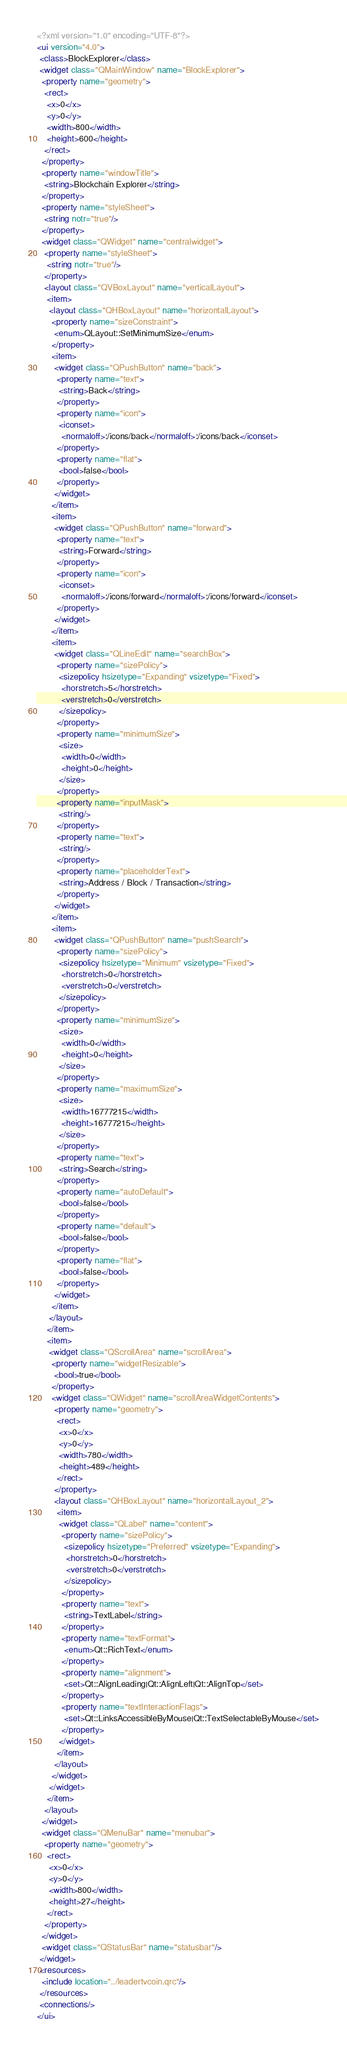Convert code to text. <code><loc_0><loc_0><loc_500><loc_500><_XML_><?xml version="1.0" encoding="UTF-8"?>
<ui version="4.0">
 <class>BlockExplorer</class>
 <widget class="QMainWindow" name="BlockExplorer">
  <property name="geometry">
   <rect>
    <x>0</x>
    <y>0</y>
    <width>800</width>
    <height>600</height>
   </rect>
  </property>
  <property name="windowTitle">
   <string>Blockchain Explorer</string>
  </property>
  <property name="styleSheet">
   <string notr="true"/>
  </property>
  <widget class="QWidget" name="centralwidget">
   <property name="styleSheet">
    <string notr="true"/>
   </property>
   <layout class="QVBoxLayout" name="verticalLayout">
    <item>
     <layout class="QHBoxLayout" name="horizontalLayout">
      <property name="sizeConstraint">
       <enum>QLayout::SetMinimumSize</enum>
      </property>
      <item>
       <widget class="QPushButton" name="back">
        <property name="text">
         <string>Back</string>
        </property>
        <property name="icon">
         <iconset>
          <normaloff>:/icons/back</normaloff>:/icons/back</iconset>
        </property>
        <property name="flat">
         <bool>false</bool>
        </property>
       </widget>
      </item>
      <item>
       <widget class="QPushButton" name="forward">
        <property name="text">
         <string>Forward</string>
        </property>
        <property name="icon">
         <iconset>
          <normaloff>:/icons/forward</normaloff>:/icons/forward</iconset>
        </property>
       </widget>
      </item>
      <item>
       <widget class="QLineEdit" name="searchBox">
        <property name="sizePolicy">
         <sizepolicy hsizetype="Expanding" vsizetype="Fixed">
          <horstretch>5</horstretch>
          <verstretch>0</verstretch>
         </sizepolicy>
        </property>
        <property name="minimumSize">
         <size>
          <width>0</width>
          <height>0</height>
         </size>
        </property>
        <property name="inputMask">
         <string/>
        </property>
        <property name="text">
         <string/>
        </property>
        <property name="placeholderText">
         <string>Address / Block / Transaction</string>
        </property>
       </widget>
      </item>
      <item>
       <widget class="QPushButton" name="pushSearch">
        <property name="sizePolicy">
         <sizepolicy hsizetype="Minimum" vsizetype="Fixed">
          <horstretch>0</horstretch>
          <verstretch>0</verstretch>
         </sizepolicy>
        </property>
        <property name="minimumSize">
         <size>
          <width>0</width>
          <height>0</height>
         </size>
        </property>
        <property name="maximumSize">
         <size>
          <width>16777215</width>
          <height>16777215</height>
         </size>
        </property>
        <property name="text">
         <string>Search</string>
        </property>
        <property name="autoDefault">
         <bool>false</bool>
        </property>
        <property name="default">
         <bool>false</bool>
        </property>
        <property name="flat">
         <bool>false</bool>
        </property>
       </widget>
      </item>
     </layout>
    </item>
    <item>
     <widget class="QScrollArea" name="scrollArea">
      <property name="widgetResizable">
       <bool>true</bool>
      </property>
      <widget class="QWidget" name="scrollAreaWidgetContents">
       <property name="geometry">
        <rect>
         <x>0</x>
         <y>0</y>
         <width>780</width>
         <height>489</height>
        </rect>
       </property>
       <layout class="QHBoxLayout" name="horizontalLayout_2">
        <item>
         <widget class="QLabel" name="content">
          <property name="sizePolicy">
           <sizepolicy hsizetype="Preferred" vsizetype="Expanding">
            <horstretch>0</horstretch>
            <verstretch>0</verstretch>
           </sizepolicy>
          </property>
          <property name="text">
           <string>TextLabel</string>
          </property>
          <property name="textFormat">
           <enum>Qt::RichText</enum>
          </property>
          <property name="alignment">
           <set>Qt::AlignLeading|Qt::AlignLeft|Qt::AlignTop</set>
          </property>
          <property name="textInteractionFlags">
           <set>Qt::LinksAccessibleByMouse|Qt::TextSelectableByMouse</set>
          </property>
         </widget>
        </item>
       </layout>
      </widget>
     </widget>
    </item>
   </layout>
  </widget>
  <widget class="QMenuBar" name="menubar">
   <property name="geometry">
    <rect>
     <x>0</x>
     <y>0</y>
     <width>800</width>
     <height>27</height>
    </rect>
   </property>
  </widget>
  <widget class="QStatusBar" name="statusbar"/>
 </widget>
 <resources>
  <include location="../leadertvcoin.qrc"/>
 </resources>
 <connections/>
</ui>
</code> 